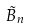Convert formula to latex. <formula><loc_0><loc_0><loc_500><loc_500>\tilde { B } _ { n }</formula> 